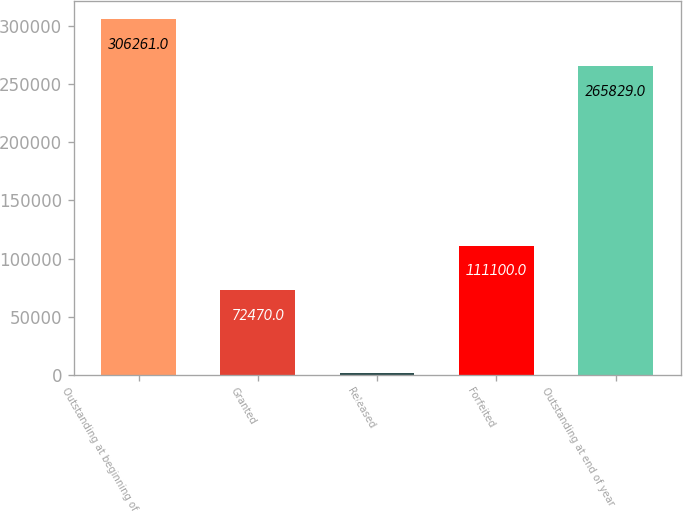Convert chart to OTSL. <chart><loc_0><loc_0><loc_500><loc_500><bar_chart><fcel>Outstanding at beginning of<fcel>Granted<fcel>Released<fcel>Forfeited<fcel>Outstanding at end of year<nl><fcel>306261<fcel>72470<fcel>1802<fcel>111100<fcel>265829<nl></chart> 